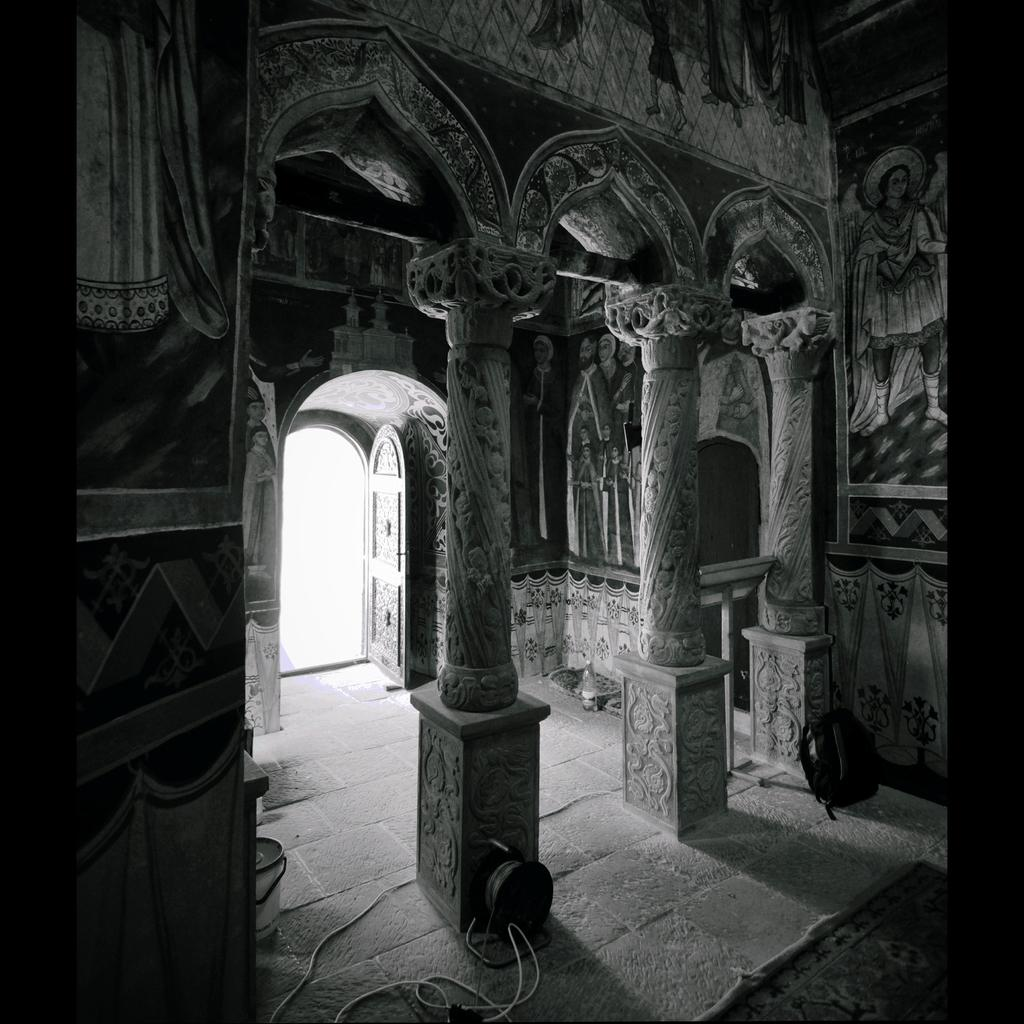What is the color scheme of the image? The image is black and white. What architectural features can be seen in the image? There are pillars and a door visible in the image. What type of artwork is present in the image? There are paintings in the image. What type of structure is depicted in the image? There is a wall in the image. What type of engine can be seen in the image? There is no engine present in the image; it features architectural elements and artwork. What color is the copper in the image? There is no copper present in the image. 